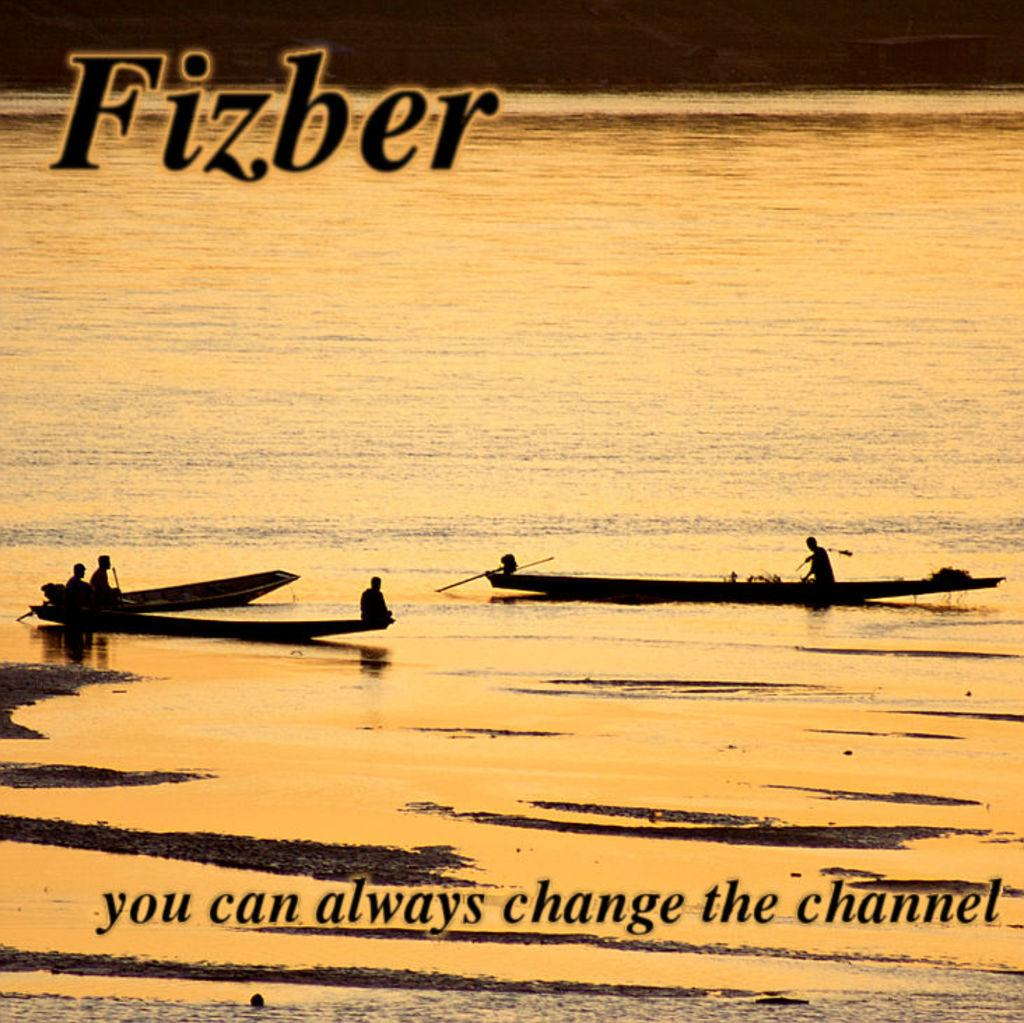What is the primary element in the image? There is water in the image. What is floating on the water? There are boats in the water. Who is in the boats? People are present in the boats. What is written on the image? There is text written at the top and bottom of the image. How many pigs are flying a kite in the image? There are no pigs or kites present in the image. What type of substance is being used to create the boats in the image? The boats in the image are not made of a substance; they are separate objects floating on the water. 